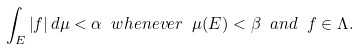<formula> <loc_0><loc_0><loc_500><loc_500>\int _ { E } \left | f \right | d \mu < \alpha \ w h e n e v e r \ \mu ( E ) < \beta \ a n d \ f \in \Lambda .</formula> 